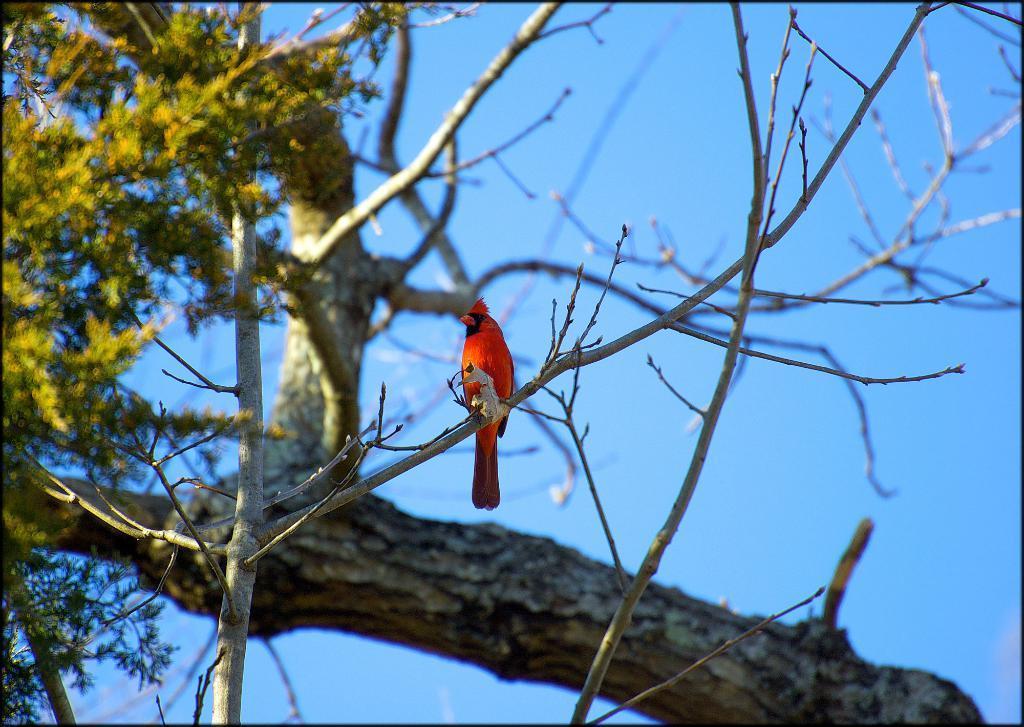Can you describe this image briefly? As we can see in the image there is a tree, bird and sky. 